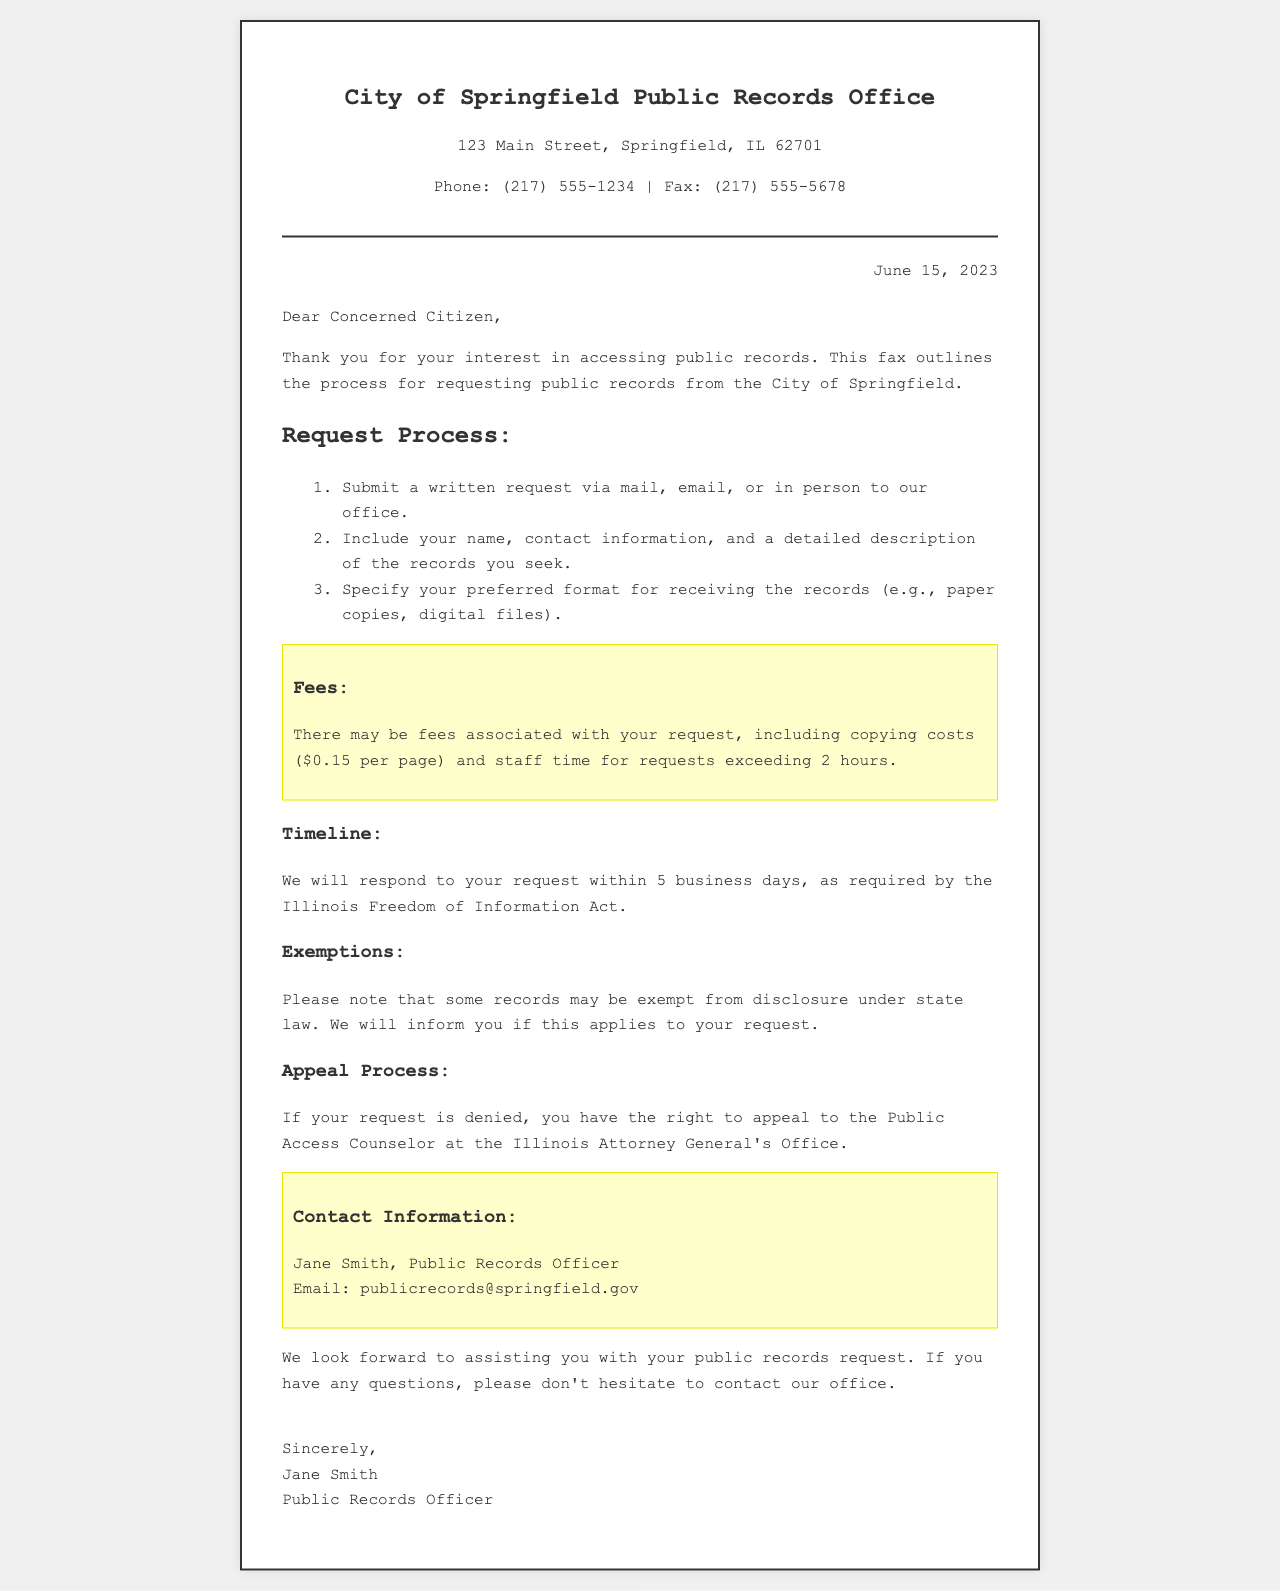What is the name of the office? The name of the office mentioned in the document is "Public Records Office."
Answer: Public Records Office What is the address of the office? The address is located in Springfield, as specified in the document.
Answer: 123 Main Street, Springfield, IL 62701 What is the phone number for the office? The document provides a contact number for the office.
Answer: (217) 555-1234 What is the fee per page for copies? The document states the cost associated with copying records per page.
Answer: $0.15 per page How many business days will it take to respond? The document outlines the timeline for responding to requests.
Answer: 5 business days What is required in the written request? The document specifies what information should be included in a written request.
Answer: Name, contact information, and a detailed description of the records Who is the Public Records Officer? The signature section of the document identifies the Public Records Officer.
Answer: Jane Smith What should you do if your request is denied? The document explains the next steps if a request for records is not granted.
Answer: Appeal to the Public Access Counselor What email address can be used for contact? The document provides an email address for communication regarding public records.
Answer: publicrecords@springfield.gov 